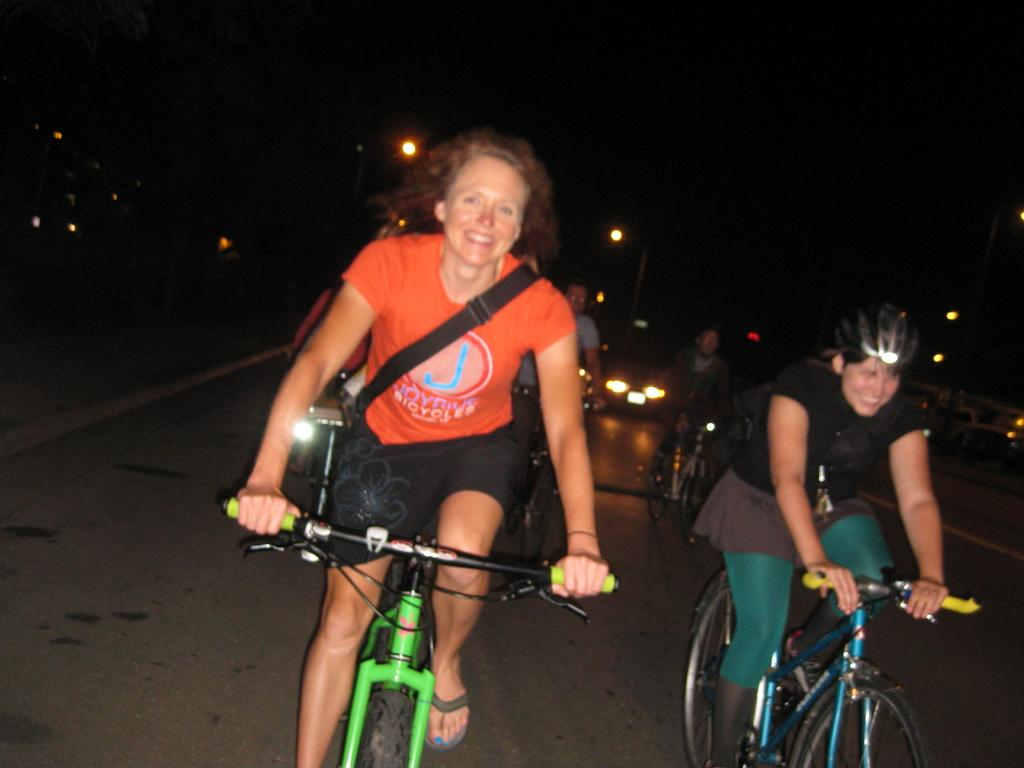How many people are in the image? There are five people in the image. What are the people doing in the image? The people are riding bicycles. Where are the bicycles located? The bicycles are on a road. What is happening in the background of the image? There are vehicles moving in the background. Can you see any visible veins on the bicycles in the image? There are no visible veins on the bicycles in the image, as bicycles do not have veins. 